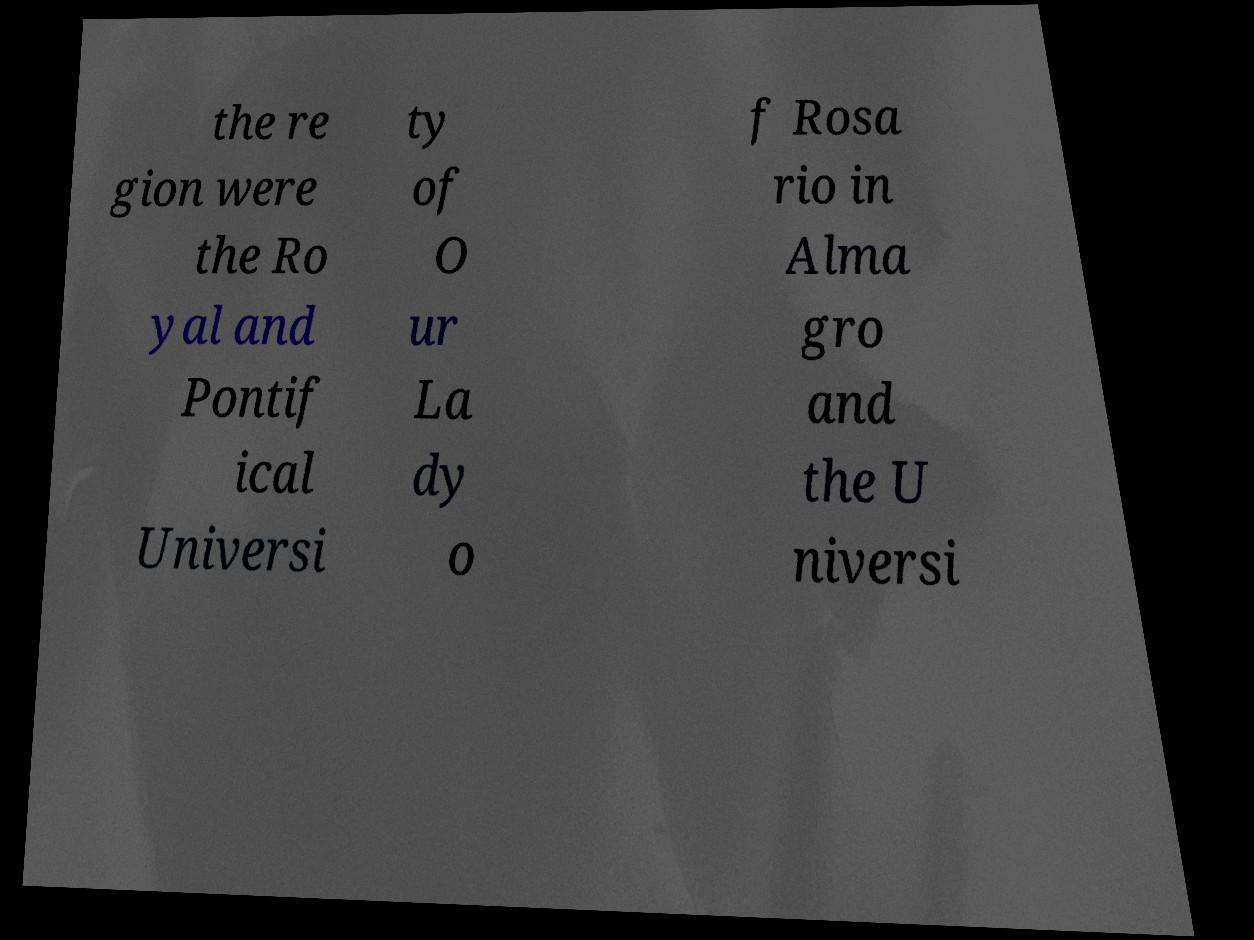There's text embedded in this image that I need extracted. Can you transcribe it verbatim? the re gion were the Ro yal and Pontif ical Universi ty of O ur La dy o f Rosa rio in Alma gro and the U niversi 